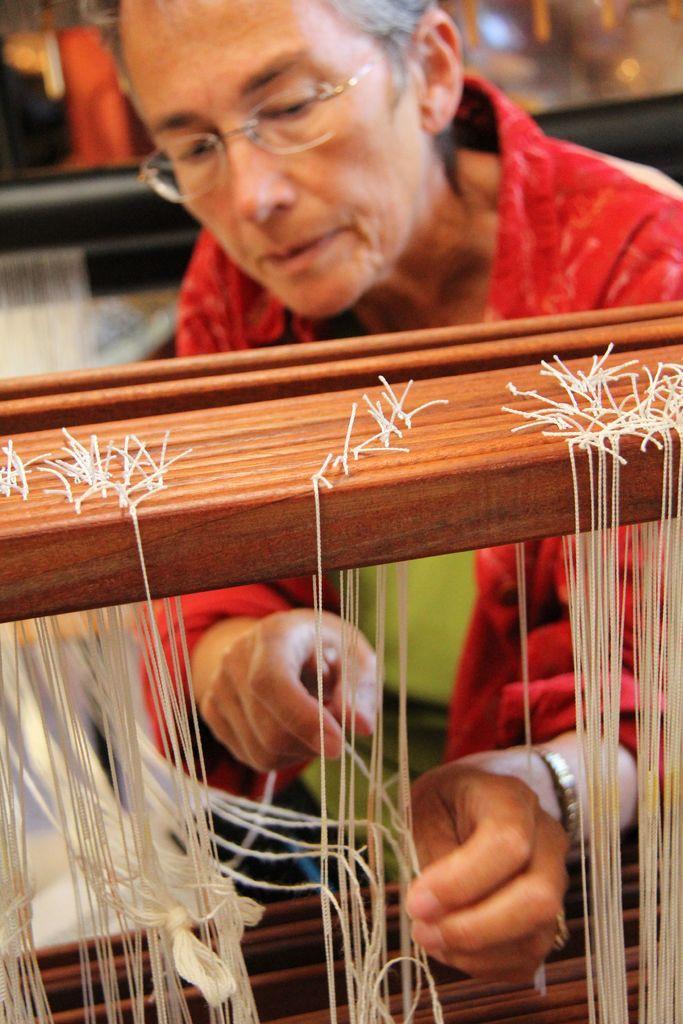Describe this image in one or two sentences. In this picture I can see a woman, she wore spectacles and i can see threads and it might be a hand weaving machine. 